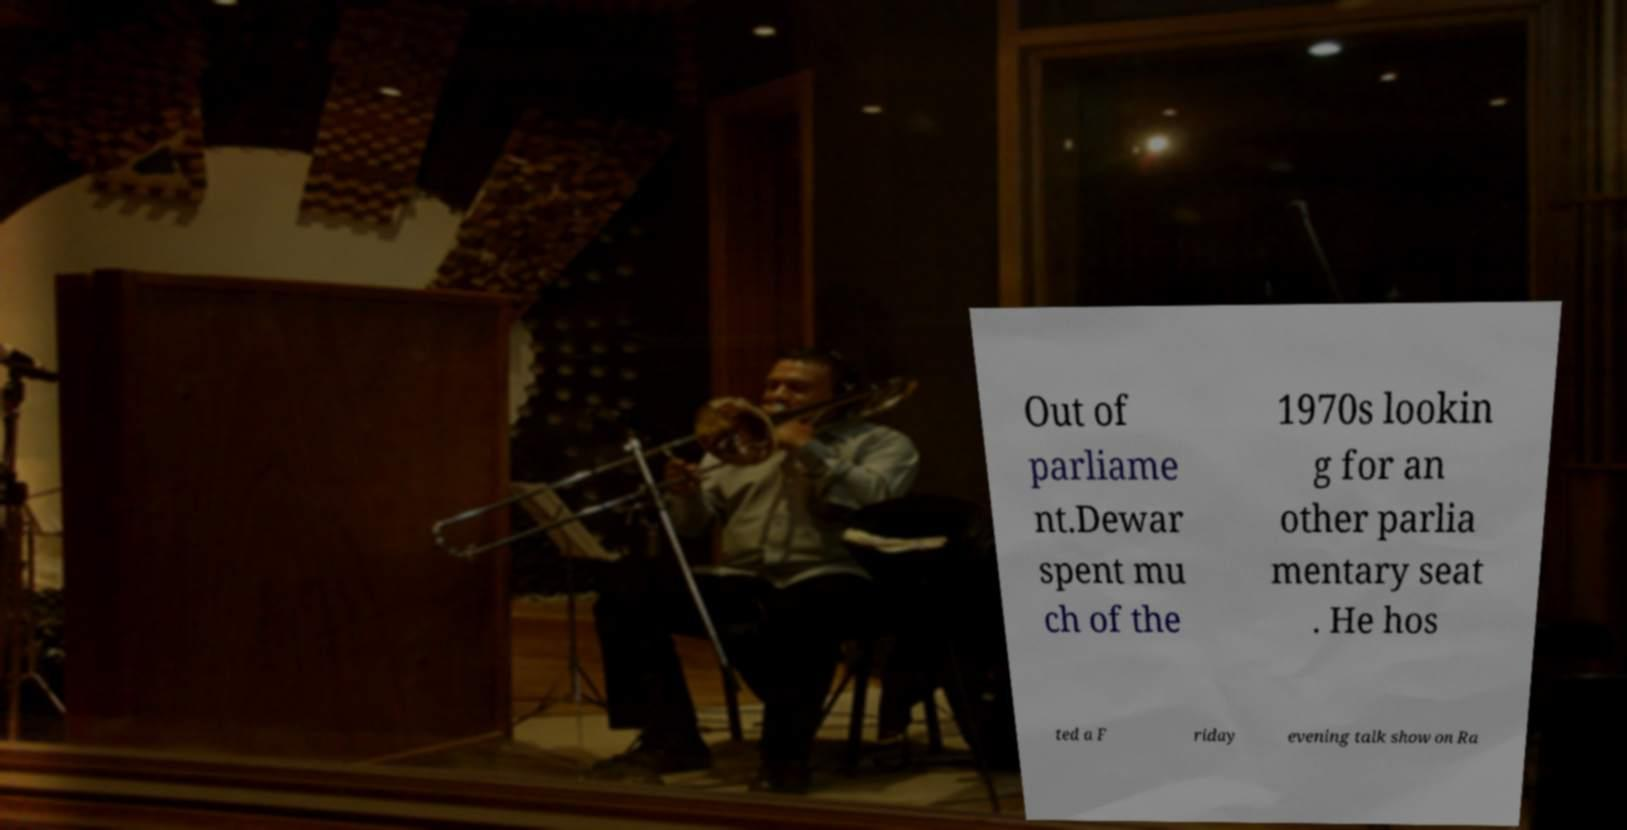Can you read and provide the text displayed in the image?This photo seems to have some interesting text. Can you extract and type it out for me? Out of parliame nt.Dewar spent mu ch of the 1970s lookin g for an other parlia mentary seat . He hos ted a F riday evening talk show on Ra 